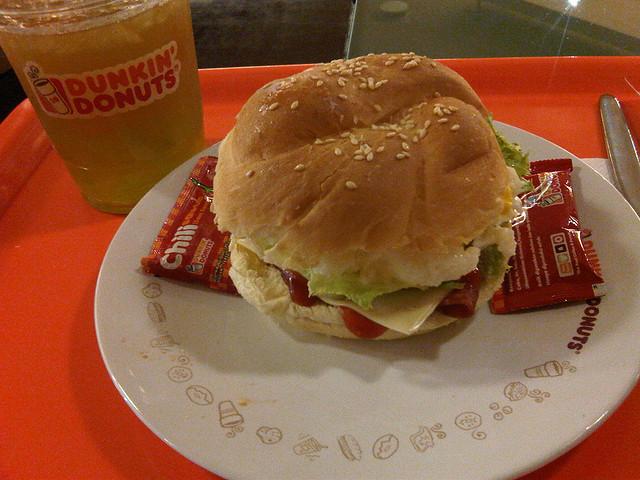Where are the sesame seeds?
Answer briefly. On bun. Has this sandwich been eaten yet?
Concise answer only. No. What is the brand name on the cup?
Short answer required. Dunkin donuts. What color is the plate?
Write a very short answer. White. What well-known franchise is the sandwich from?
Write a very short answer. Dunkin donuts. 